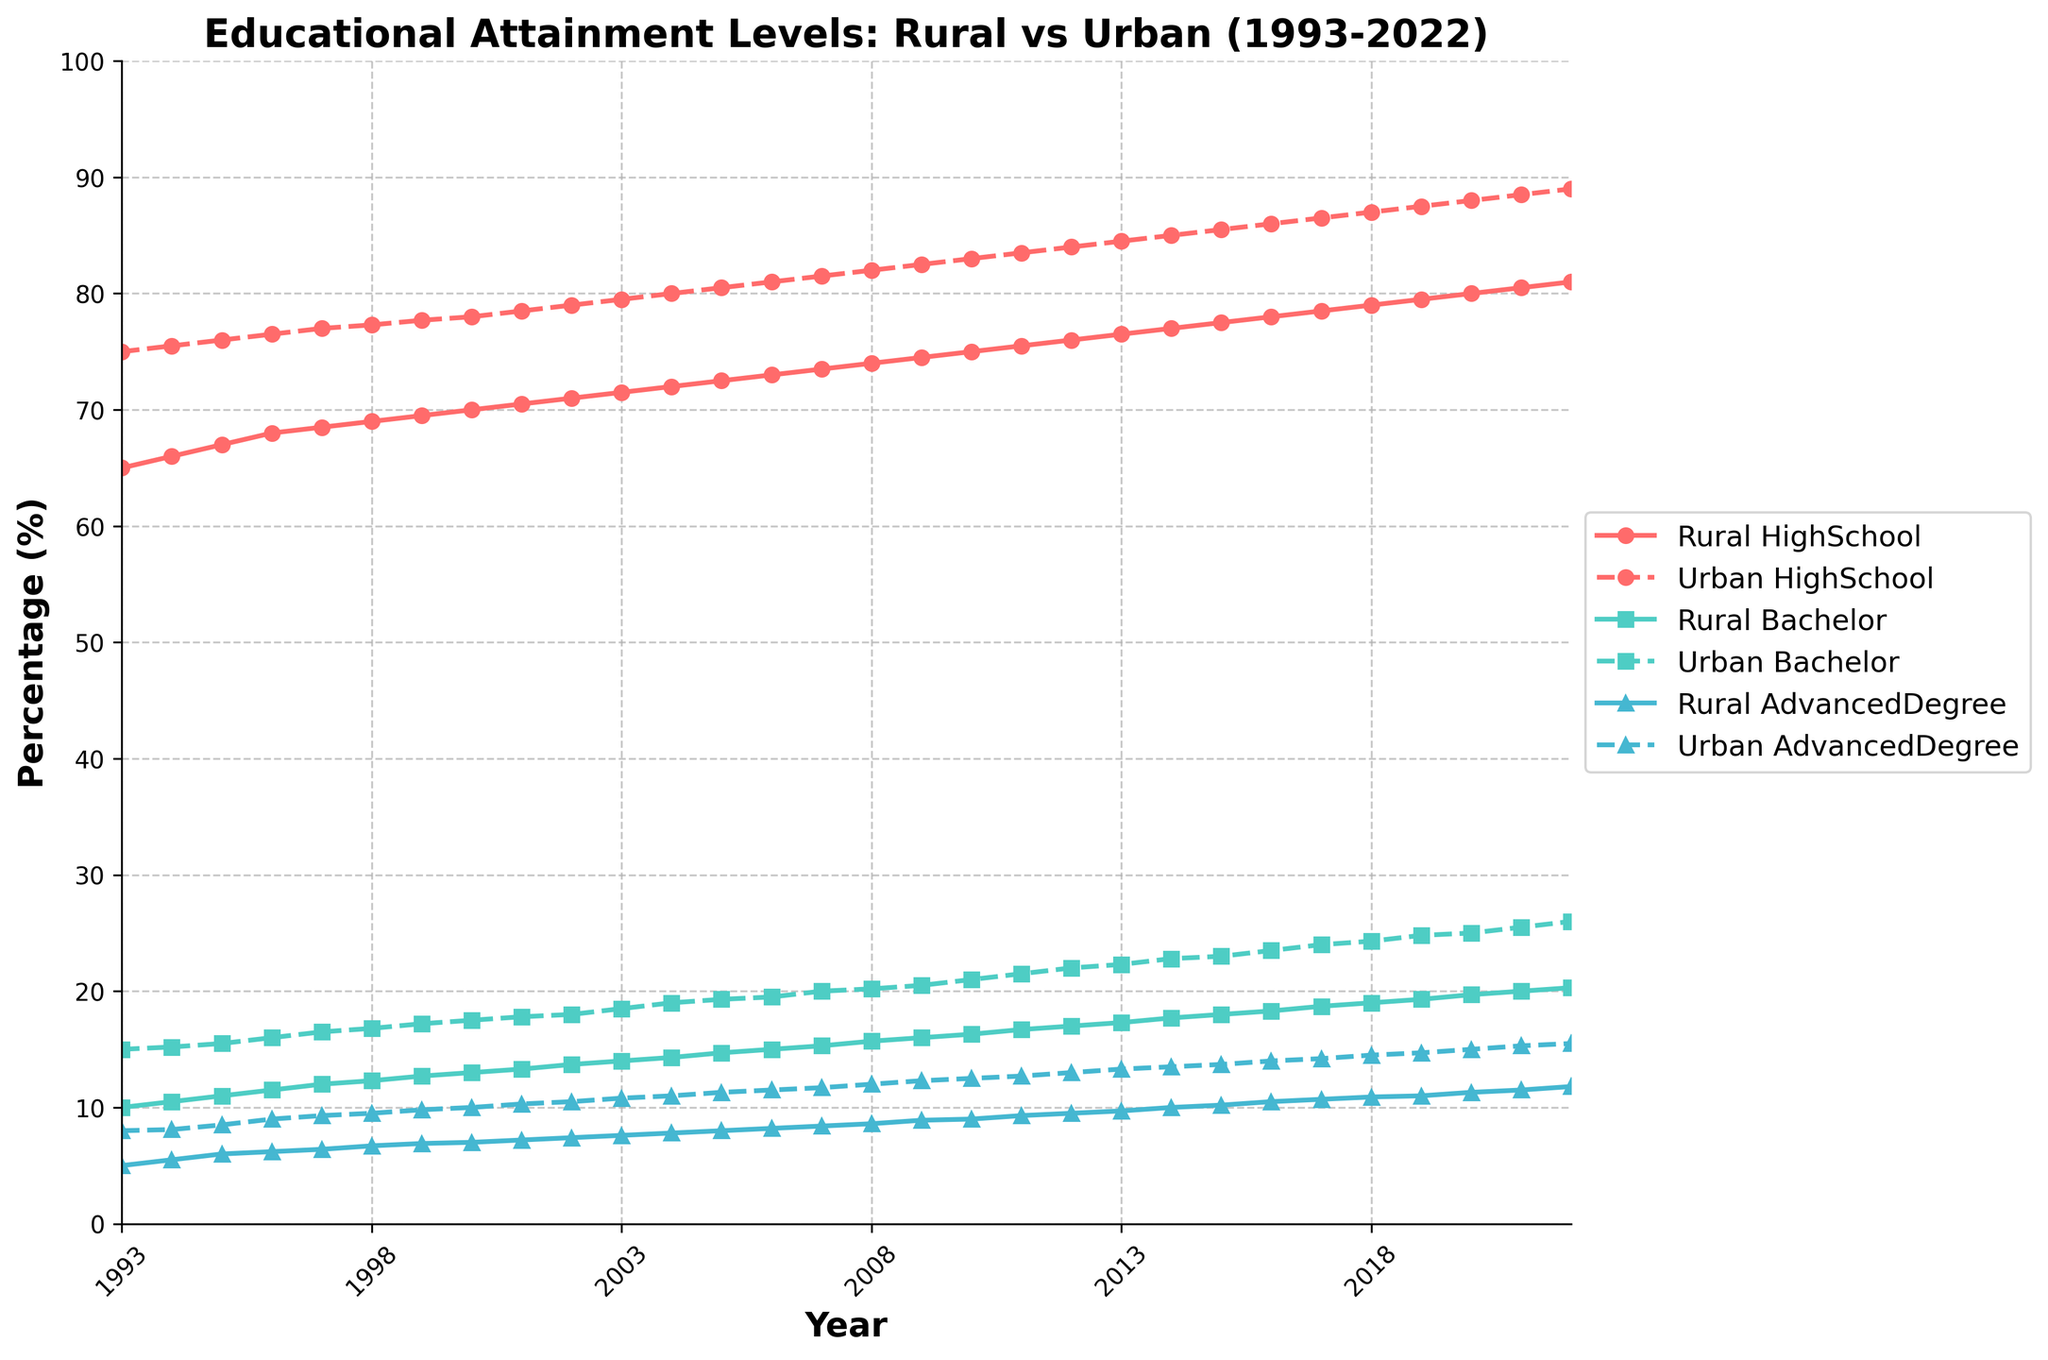What is the title of the figure? The title of the figure is displayed prominently at the top and is meant to give an overview of what is being depicted. In this case, the title is "Educational Attainment Levels: Rural vs Urban (1993-2022)."
Answer: Educational Attainment Levels: Rural vs Urban (1993-2022) What do the x-axis and y-axis represent in the figure? The x-axis represents the years from 1993 to 2022, while the y-axis represents the percentage (%) of educational attainment levels.
Answer: The x-axis represents years and the y-axis represents percentage (%) Which educational attainment category shows the largest increase in rural areas over the 30-year period? By observing the plotted lines for rural areas, we can compare the starting and ending percentages of the three categories. Rural Bachelor's graduates start at 10% in 1993 and rise to 20.3% by 2022, which is the largest increase.
Answer: Rural Bachelor's graduates In which year does the percentage of urban High School graduates reach 85%? By following the Urban High School graduates line, we can locate the year where the y-value first hits 85%. It occurs around the year 2014.
Answer: 2014 How does the trend of urban Advanced Degree graduates compare to rural Advanced Degree graduates over the years? By comparing the two lines representing urban and rural Advanced Degree graduates, we can see that both show an increasing trend. The urban Advanced Degree graduates start higher and increase at a slightly faster rate compared to rural Advanced Degree graduates.
Answer: Both show an increasing trend, but urban is higher and increases slightly faster What is the difference in the percentage of rural and urban High School graduates in 2000? To determine the difference, locate the percentages for rural and urban High School graduates in the year 2000 from the plot. Rural High School graduates are at 70%, and urban High School graduates are at 78%, resulting in a difference of 8%.
Answer: 8% Between 1993 to 2022, which has a higher percentage increase: rural Advanced Degree graduates or urban Bachelor's graduates? We first find the initial and final percentages for both categories. Rural Advanced Degree graduates go from 5% to 11.8%, an increase of 6.8%. Urban Bachelor's graduates go from 15% to 26%, an increase of 11%. By comparing these increases, we see that urban Bachelor's graduates have a higher percentage increase.
Answer: Urban Bachelor's graduates What is the average percentage of rural High School graduates from 1993 to 2022? To find the average percentage, sum all the yearly percentages of rural High School graduates and divide by the number of years (30). (65 + 66 + 67 + ... + 81) / 30 = (65 + 66 + 67 + 68 + 68.5 + 69 + 69.5 + 70 + 70.5 + 71 + 71.5 + 72 + 72.5 + 73 + 73.5 + 74 + 74.5 + 75 + 75.5 + 76 + 76.5 + 77 + 77.5 + 78 + 78.5 + 79 + 79.5 + 80 + 80.5 + 81) / 30 = 73.3833.
Answer: 73.38% Which category has the smallest gap between rural and urban percentages in 2022? By examining the differences between the rural and urban percentages for each category in 2022, we see that the smallest gap is in Advanced Degree graduates, with a rural percentage of 11.8% and urban percentage of 15.5%, a gap of 3.7.
Answer: Advanced Degree graduates How do the slopes of the rural and urban lines for Bachelor's graduates compare over the first 10 years (1993-2002)? By visually assessing the plotted lines for the rural and urban Bachelor's graduates, we notice that both lines show an upward trend. However, the urban Bachelor's graduates line has a slightly steeper slope compared to the rural Bachelor's graduates line, indicating a faster increase.
Answer: Urban Bachelor's graduates have a steeper slope 